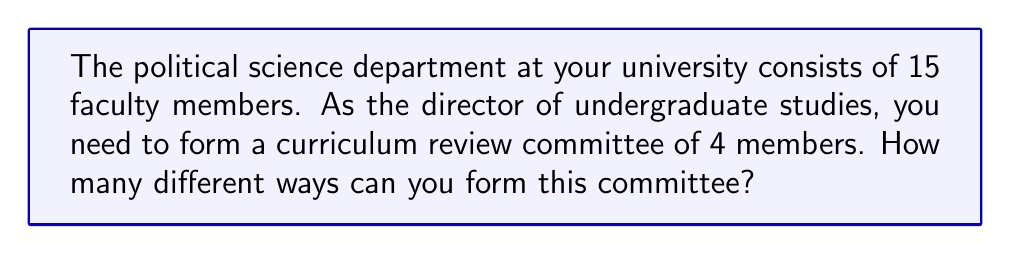Can you solve this math problem? To solve this problem, we need to use the combination formula. This is because:

1. The order of selection doesn't matter (e.g., selecting professors A, B, C, and D is the same as selecting B, C, A, and D).
2. We are selecting a subset of the total group.
3. Each faculty member can only be selected once.

The combination formula is:

$${n \choose k} = \frac{n!}{k!(n-k)!}$$

Where:
$n$ is the total number of items to choose from (in this case, 15 faculty members)
$k$ is the number of items being chosen (in this case, 4 committee members)

Plugging in our values:

$${15 \choose 4} = \frac{15!}{4!(15-4)!} = \frac{15!}{4!11!}$$

Now, let's calculate this step-by-step:

$$\frac{15 \cdot 14 \cdot 13 \cdot 12 \cdot 11!}{(4 \cdot 3 \cdot 2 \cdot 1) \cdot 11!}$$

The 11! cancels out in the numerator and denominator:

$$\frac{15 \cdot 14 \cdot 13 \cdot 12}{4 \cdot 3 \cdot 2 \cdot 1}$$

$$= \frac{32,760}{24} = 1,365$$

Therefore, there are 1,365 different ways to form the committee.
Answer: 1,365 different committee formations 